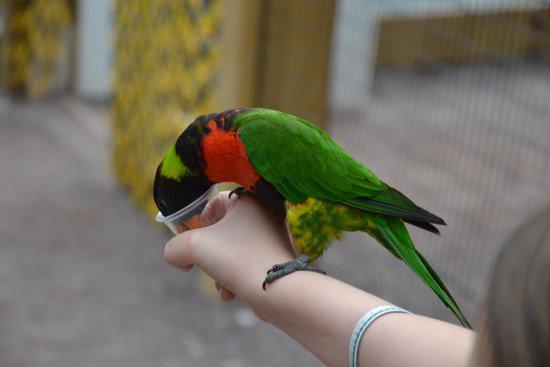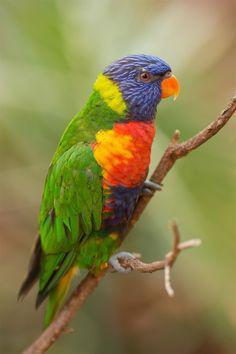The first image is the image on the left, the second image is the image on the right. Examine the images to the left and right. Is the description "Three birds perch on a branch in the image on the left." accurate? Answer yes or no. No. The first image is the image on the left, the second image is the image on the right. Examine the images to the left and right. Is the description "The left image shows exactly three multicolored parrots." accurate? Answer yes or no. No. 